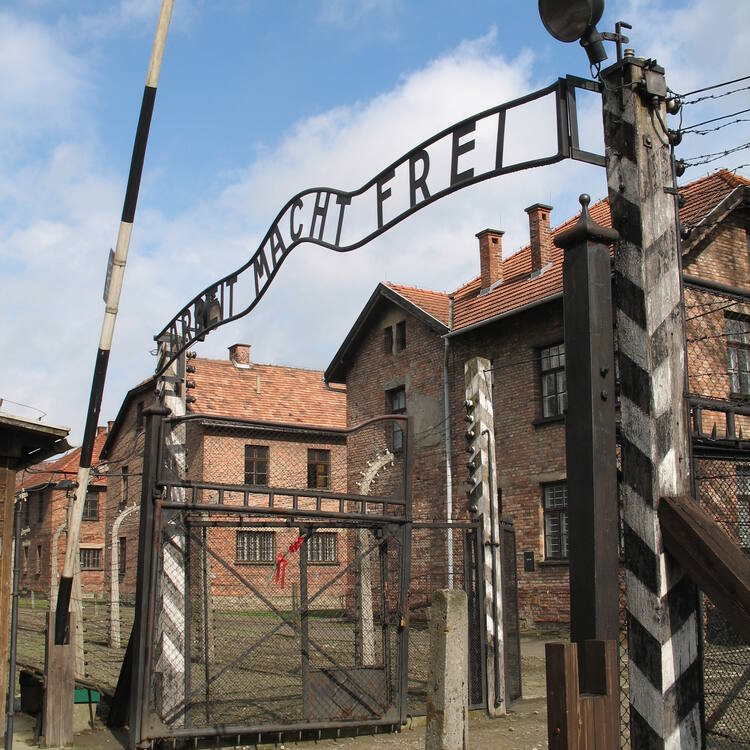Imagine a scenario where this image comes to life, describe what happens. In a vivid and eerie scenario, the sun begins to set as the shadows of the towering gate grow longer. The once static image comes alive with a ghostly procession of silent figures, dressed in tattered striped uniforms, moving towards the gate. They are spectral echoes of the countless lives that once passed through this gate, their expressions a mixture of despair and resilience. As they walk, faint whispers of their stories intermingle in the air, creating a haunting symphony of voices that speak of suffering and hope. The sound of marching boots, the clanking of tools, and distant, mournful cries fill the atmosphere, transforming the peaceful scene into a chilling reminder of the past. As the last rays of sunlight disappear, the ghosts fade back into the shadows, leaving behind an intensified essence of memory and history. 